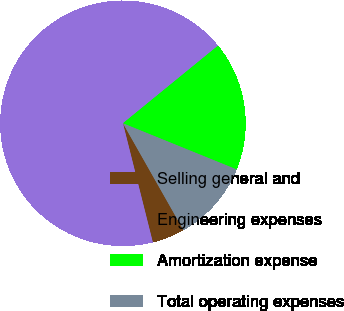Convert chart to OTSL. <chart><loc_0><loc_0><loc_500><loc_500><pie_chart><fcel>Selling general and<fcel>Engineering expenses<fcel>Amortization expense<fcel>Total operating expenses<nl><fcel>4.29%<fcel>68.01%<fcel>17.03%<fcel>10.66%<nl></chart> 